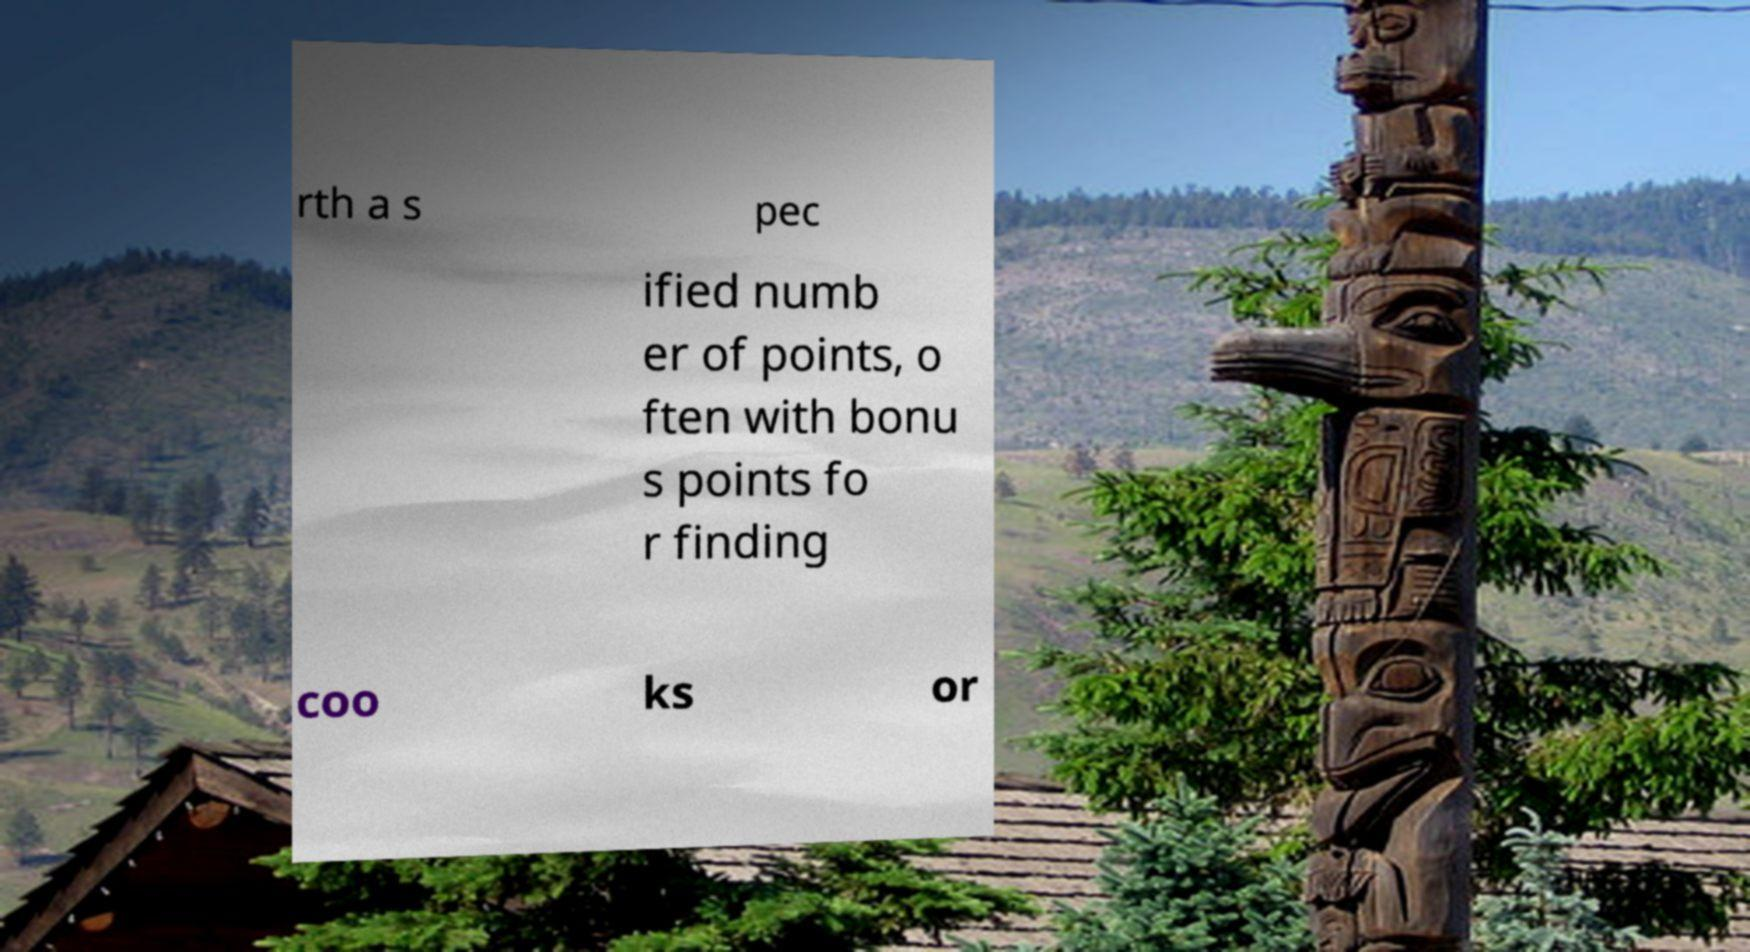For documentation purposes, I need the text within this image transcribed. Could you provide that? rth a s pec ified numb er of points, o ften with bonu s points fo r finding coo ks or 